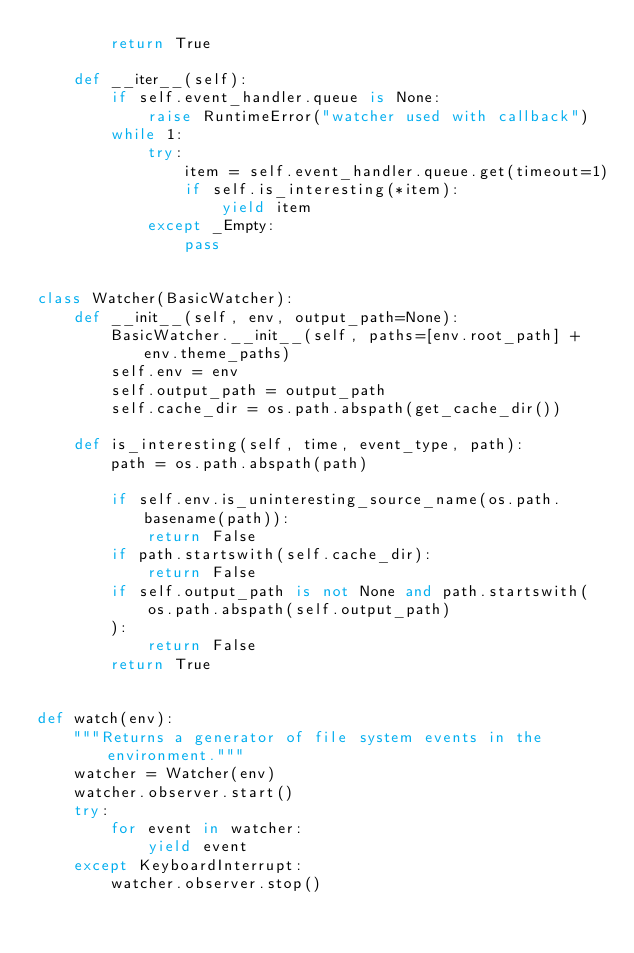Convert code to text. <code><loc_0><loc_0><loc_500><loc_500><_Python_>        return True

    def __iter__(self):
        if self.event_handler.queue is None:
            raise RuntimeError("watcher used with callback")
        while 1:
            try:
                item = self.event_handler.queue.get(timeout=1)
                if self.is_interesting(*item):
                    yield item
            except _Empty:
                pass


class Watcher(BasicWatcher):
    def __init__(self, env, output_path=None):
        BasicWatcher.__init__(self, paths=[env.root_path] + env.theme_paths)
        self.env = env
        self.output_path = output_path
        self.cache_dir = os.path.abspath(get_cache_dir())

    def is_interesting(self, time, event_type, path):
        path = os.path.abspath(path)

        if self.env.is_uninteresting_source_name(os.path.basename(path)):
            return False
        if path.startswith(self.cache_dir):
            return False
        if self.output_path is not None and path.startswith(
            os.path.abspath(self.output_path)
        ):
            return False
        return True


def watch(env):
    """Returns a generator of file system events in the environment."""
    watcher = Watcher(env)
    watcher.observer.start()
    try:
        for event in watcher:
            yield event
    except KeyboardInterrupt:
        watcher.observer.stop()
</code> 